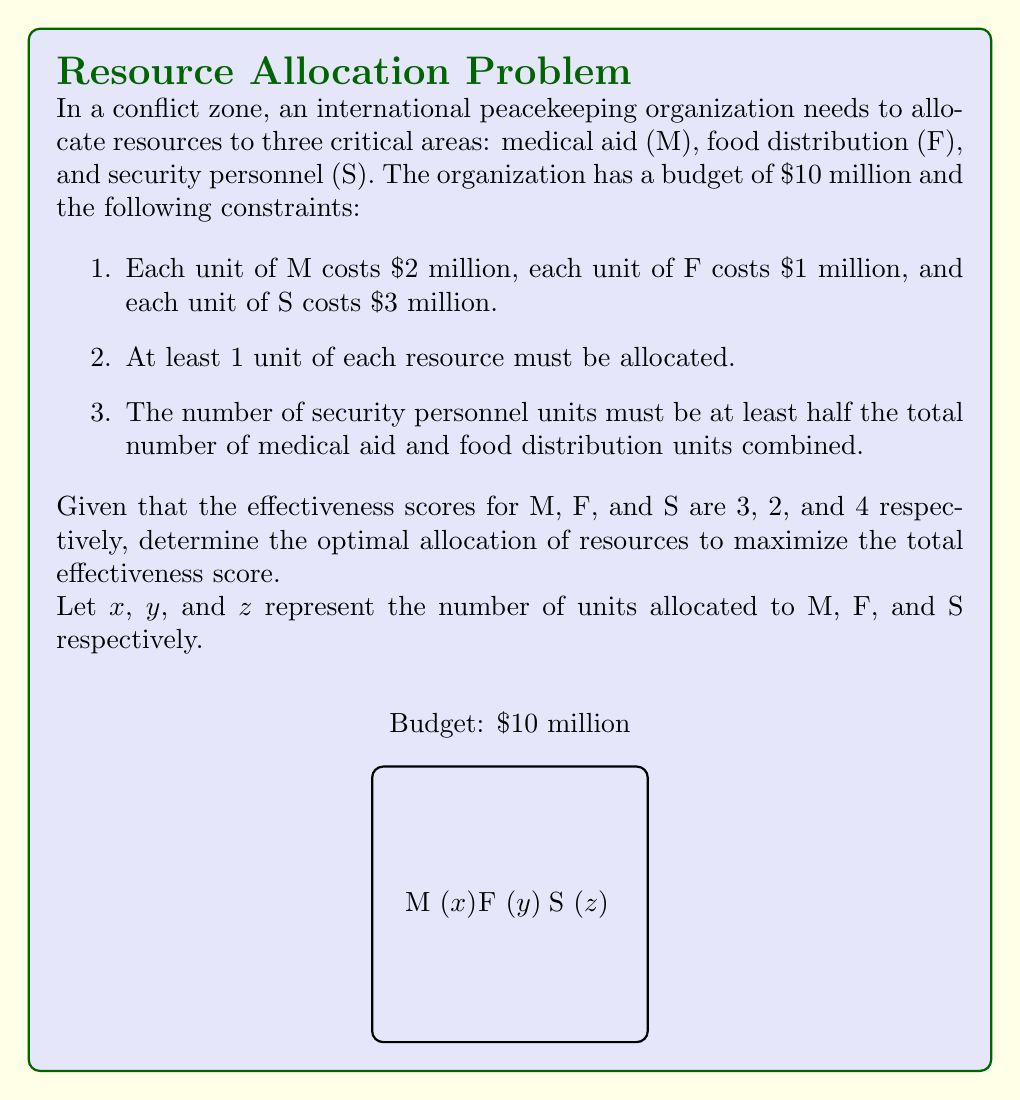Show me your answer to this math problem. To solve this linear programming problem, we'll follow these steps:

1. Define the objective function:
   Maximize $3x + 2y + 4z$

2. Set up the constraints:
   a) Budget constraint: $2x + y + 3z \leq 10$
   b) Minimum allocation: $x \geq 1$, $y \geq 1$, $z \geq 1$
   c) Security personnel constraint: $z \geq \frac{1}{2}(x + y)$

3. Convert to standard form:
   Maximize $3x + 2y + 4z$
   Subject to:
   $2x + y + 3z \leq 10$
   $-x \leq -1$
   $-y \leq -1$
   $-z \leq -1$
   $-z + \frac{1}{2}x + \frac{1}{2}y \leq 0$
   $x, y, z \geq 0$

4. Solve using the simplex method or a linear programming solver.

5. The optimal solution is:
   $x = 1$ (1 unit of medical aid)
   $y = 3$ (3 units of food distribution)
   $z = 2$ (2 units of security personnel)

6. Verify the constraints:
   Budget: $2(1) + 1(3) + 3(2) = 10$ (exactly $10 million)
   Minimum allocation: All resources have at least 1 unit
   Security personnel: $2 \geq \frac{1}{2}(1 + 3)$ is satisfied

7. Calculate the maximum effectiveness score:
   $3(1) + 2(3) + 4(2) = 3 + 6 + 8 = 17$

Therefore, the optimal allocation that maximizes the effectiveness score is 1 unit of medical aid, 3 units of food distribution, and 2 units of security personnel.
Answer: M: 1, F: 3, S: 2; Max effectiveness: 17 